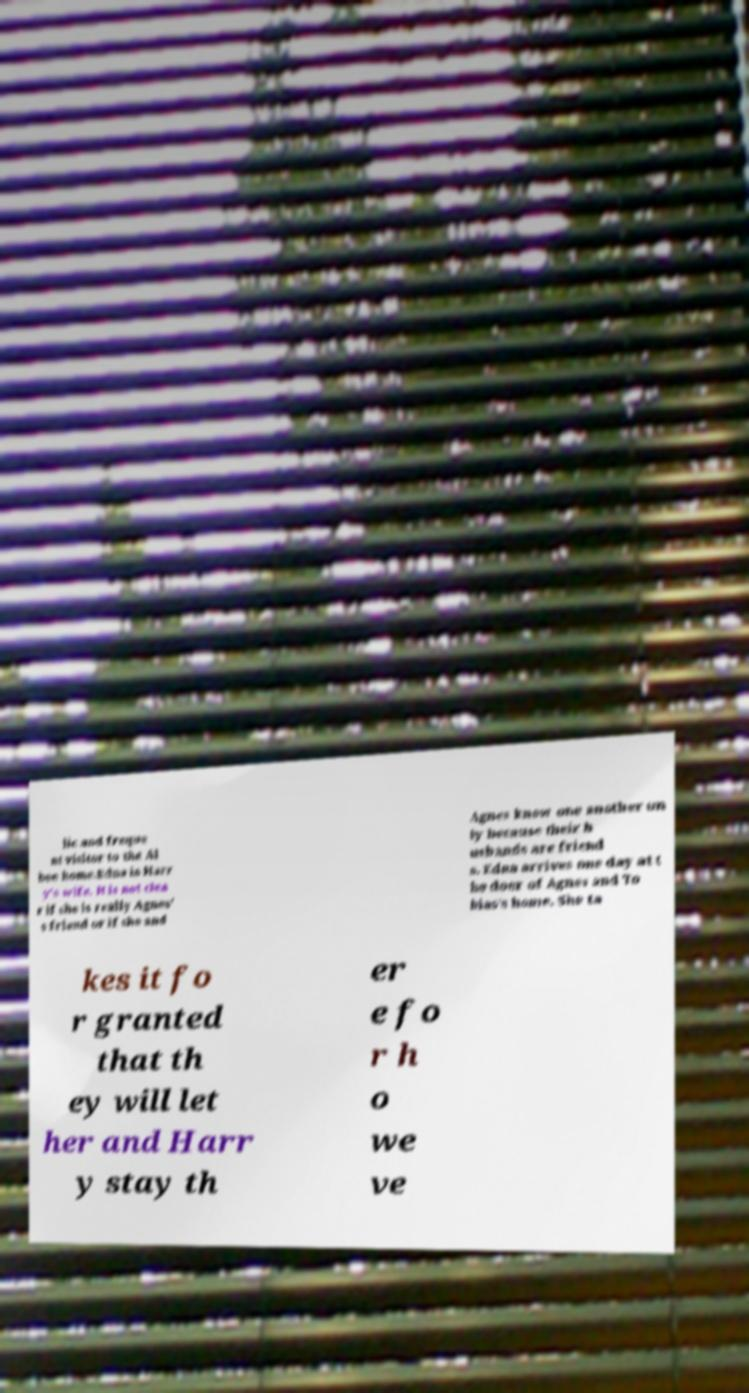There's text embedded in this image that I need extracted. Can you transcribe it verbatim? lic and freque nt visitor to the Al bee home.Edna is Harr y's wife. It is not clea r if she is really Agnes' s friend or if she and Agnes know one another on ly because their h usbands are friend s. Edna arrives one day at t he door of Agnes and To bias's home. She ta kes it fo r granted that th ey will let her and Harr y stay th er e fo r h o we ve 